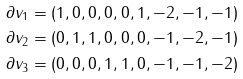<formula> <loc_0><loc_0><loc_500><loc_500>\partial v _ { 1 } & = ( 1 , 0 , 0 , 0 , 0 , 1 , - 2 , - 1 , - 1 ) \\ \partial v _ { 2 } & = ( 0 , 1 , 1 , 0 , 0 , 0 , - 1 , - 2 , - 1 ) \\ \partial v _ { 3 } & = ( 0 , 0 , 0 , 1 , 1 , 0 , - 1 , - 1 , - 2 )</formula> 